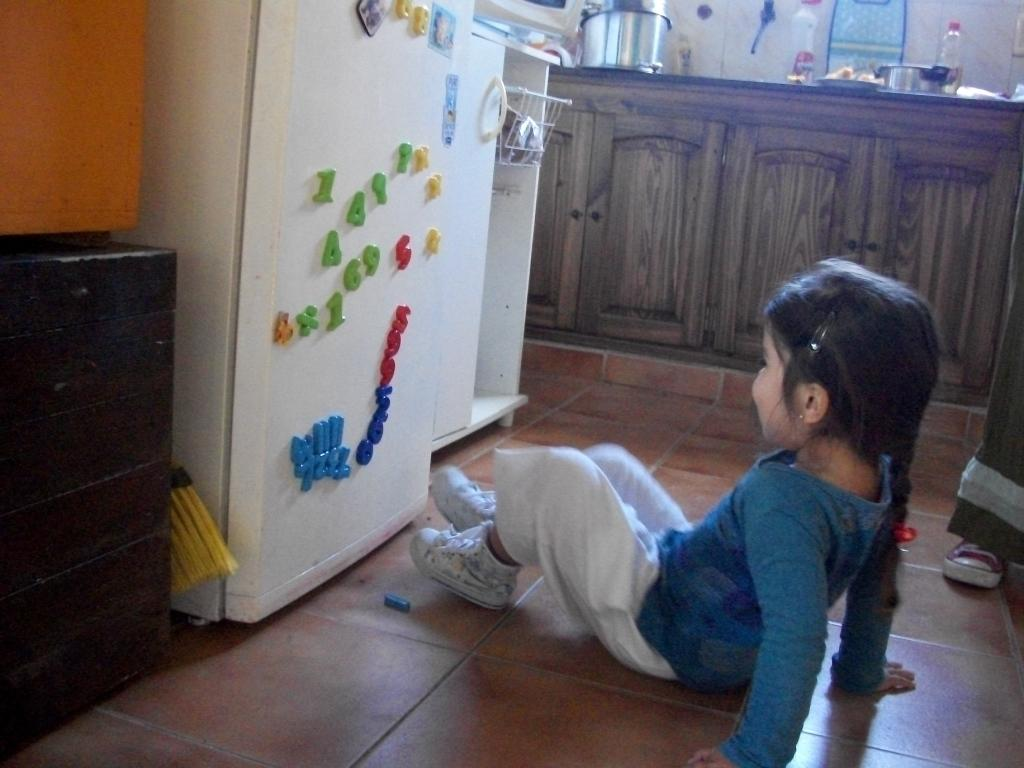<image>
Share a concise interpretation of the image provided. A little girl playing with magnets including red 5 and two red 9s 